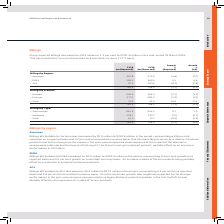According to Sophos Group's financial document, What was the amount of Group reported billings in 2019? According to the financial document, $760.3 million. The relevant text states: "lings decreased by $8.3 million or 1.1 per cent to $760.3 million in the year-ended 31 March 2019. This represented a 0.1 per cent decrease on a constant currency (“C..." Also, What was the percentage change in Group reported billings in 2019 from 2018? According to the financial document, 1.1 per cent. The relevant text states: "up reported billings decreased by $8.3 million or 1.1 per cent to $760.3 million in the year-ended 31 March 2019. This represented a 0.1 per cent decrease on a co..." Also, How is the analysis of Billings broken down in the table? The document contains multiple relevant values: Billings by Region, Billings by Product, Billings by Type. From the document: "Billings by Region: Billings by Type: Billings by Product:..." Additionally, In which year was the amount of Billings larger? According to the financial document, FY18. The relevant text states: "FY19 $m (Reported) FY18 $m (Reported)..." Also, can you calculate: What was the change in Other in 2019 from 2018 under Billings by Product? Based on the calculation: 37.3-32.0, the result is 5.3 (in millions). This is based on the information: "– Other 37.3 32.0 16.6 17.1 – Other 37.3 32.0 16.6 17.1..." The key data points involved are: 32.0, 37.3. Also, can you calculate: What was the average amount of Billings in 2018 and 2019? To answer this question, I need to perform calculations using the financial data. The calculation is: (760.3+768.6)/2, which equals 764.45 (in millions). This is based on the information: "760.3 768.6 (1.1) (0.1) 760.3 768.6 (1.1) (0.1)..." The key data points involved are: 760.3, 768.6. 